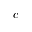<formula> <loc_0><loc_0><loc_500><loc_500>c</formula> 